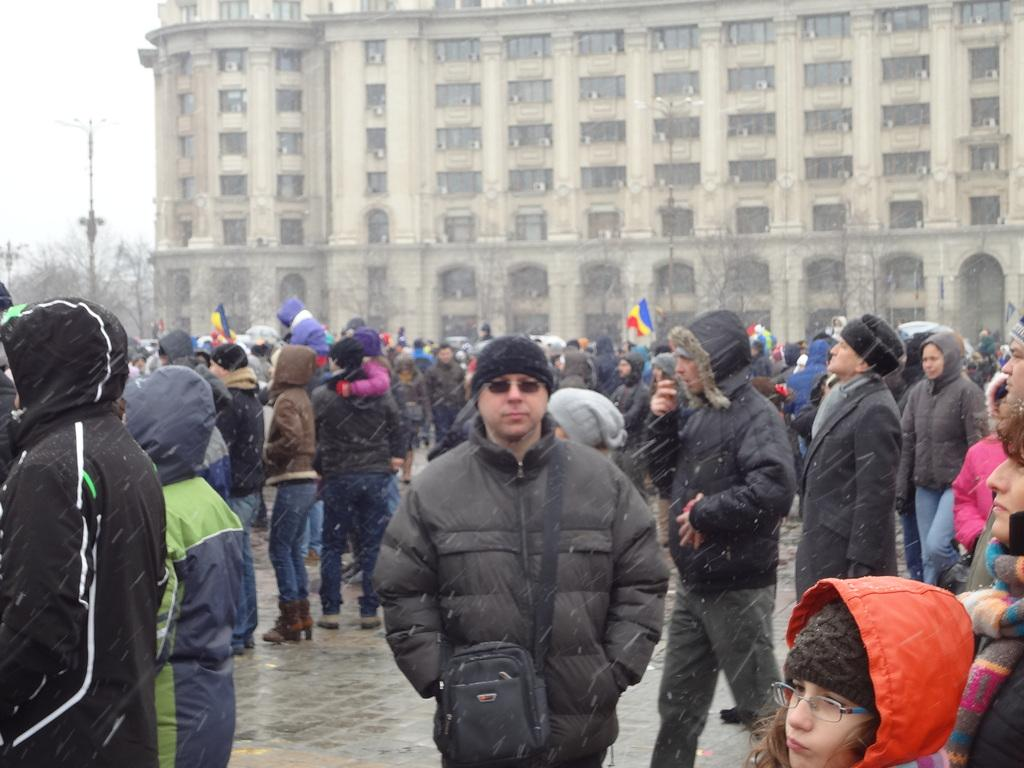What is located at the bottom of the image? There is a crowd at the bottom of the image. What can be seen in the middle of the image? There is a building and trees in the middle of the image. What is visible in the background of the image? The sky is visible in the background of the image. What type of sweater is the government wearing in the image? There is no government or sweater present in the image. What role does the parent play in the image? There is no parent present in the image. 